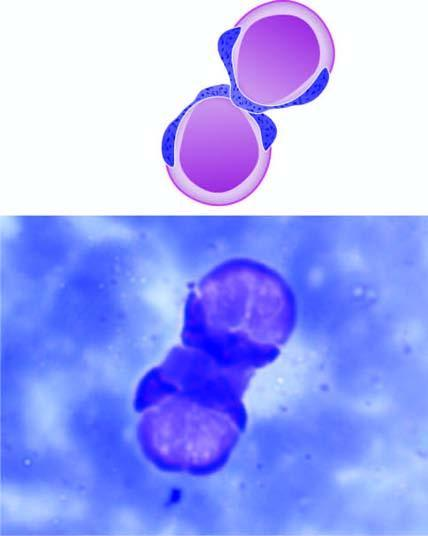re part of the endocervical mucosa two le cells having rounded masses of amorphous nuclear material which has displaced the lobes of neutrophil to the rim of the cell?
Answer the question using a single word or phrase. No 